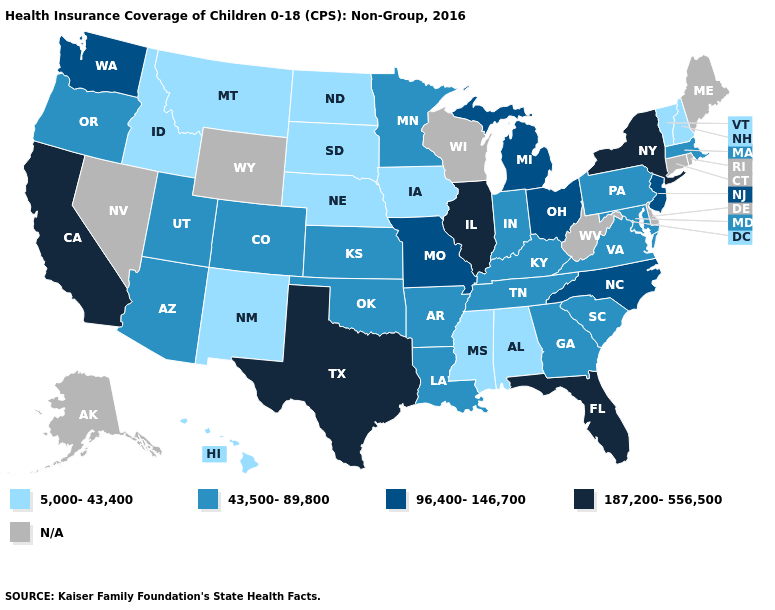What is the value of Mississippi?
Give a very brief answer. 5,000-43,400. Name the states that have a value in the range 5,000-43,400?
Be succinct. Alabama, Hawaii, Idaho, Iowa, Mississippi, Montana, Nebraska, New Hampshire, New Mexico, North Dakota, South Dakota, Vermont. Which states have the highest value in the USA?
Be succinct. California, Florida, Illinois, New York, Texas. Name the states that have a value in the range N/A?
Concise answer only. Alaska, Connecticut, Delaware, Maine, Nevada, Rhode Island, West Virginia, Wisconsin, Wyoming. What is the value of Montana?
Answer briefly. 5,000-43,400. What is the lowest value in the USA?
Keep it brief. 5,000-43,400. Name the states that have a value in the range 43,500-89,800?
Give a very brief answer. Arizona, Arkansas, Colorado, Georgia, Indiana, Kansas, Kentucky, Louisiana, Maryland, Massachusetts, Minnesota, Oklahoma, Oregon, Pennsylvania, South Carolina, Tennessee, Utah, Virginia. Name the states that have a value in the range 187,200-556,500?
Quick response, please. California, Florida, Illinois, New York, Texas. What is the highest value in the MidWest ?
Short answer required. 187,200-556,500. What is the highest value in states that border Missouri?
Concise answer only. 187,200-556,500. Is the legend a continuous bar?
Be succinct. No. Name the states that have a value in the range 43,500-89,800?
Quick response, please. Arizona, Arkansas, Colorado, Georgia, Indiana, Kansas, Kentucky, Louisiana, Maryland, Massachusetts, Minnesota, Oklahoma, Oregon, Pennsylvania, South Carolina, Tennessee, Utah, Virginia. Name the states that have a value in the range 43,500-89,800?
Give a very brief answer. Arizona, Arkansas, Colorado, Georgia, Indiana, Kansas, Kentucky, Louisiana, Maryland, Massachusetts, Minnesota, Oklahoma, Oregon, Pennsylvania, South Carolina, Tennessee, Utah, Virginia. 